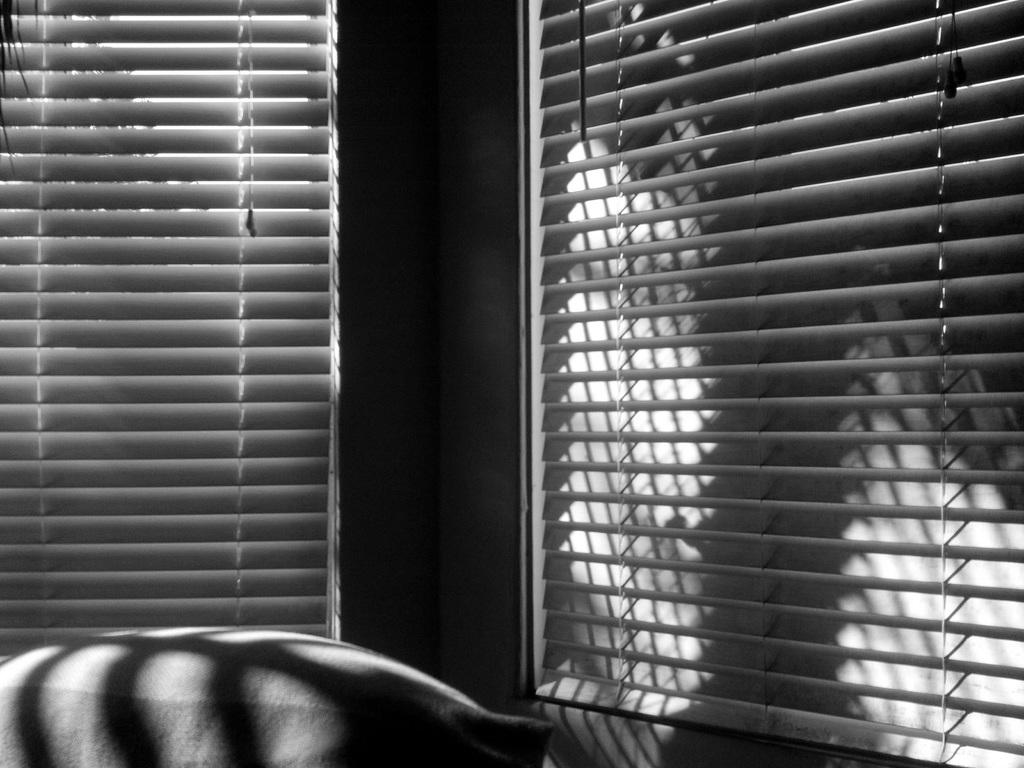What is located in the foreground of the image? There is an object in the foreground of the image. Can you describe the position of the object in the image? The object is at the bottom of the image. What type of window treatment can be seen in the image? Window blinds are visible in the image. How many oranges are being held in the mouth of the person in the image? There is no person or oranges present in the image. 